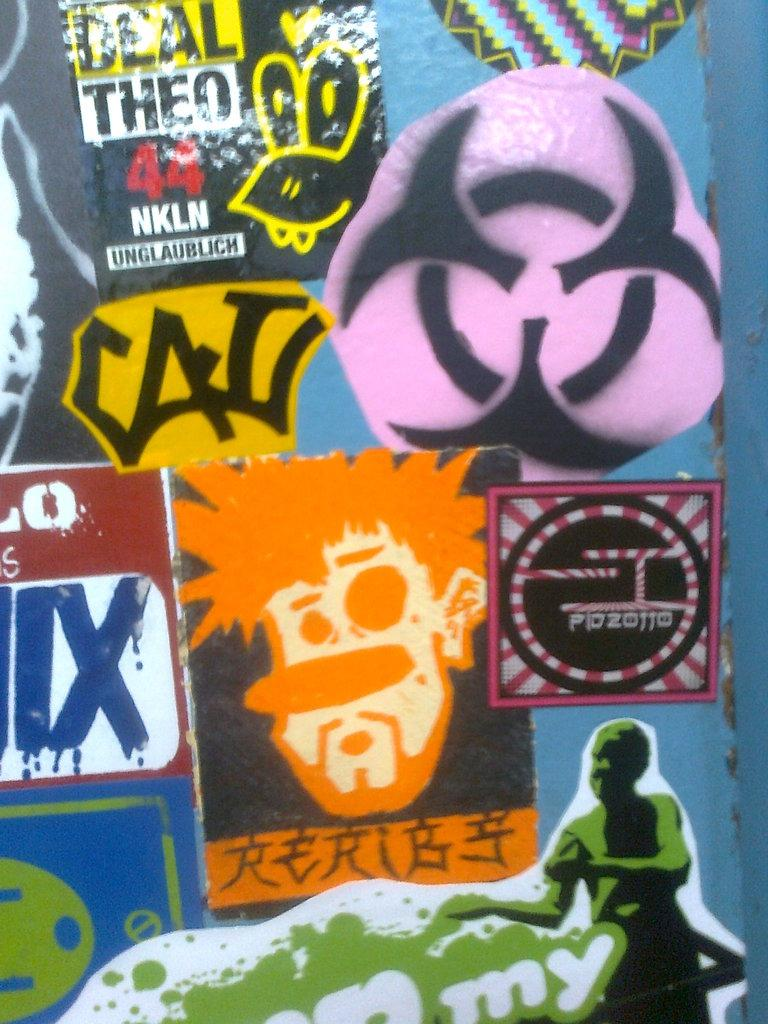<image>
Describe the image concisely. Several different colorful stickers are shown in a collage, one of which reads "Deal Theo." 